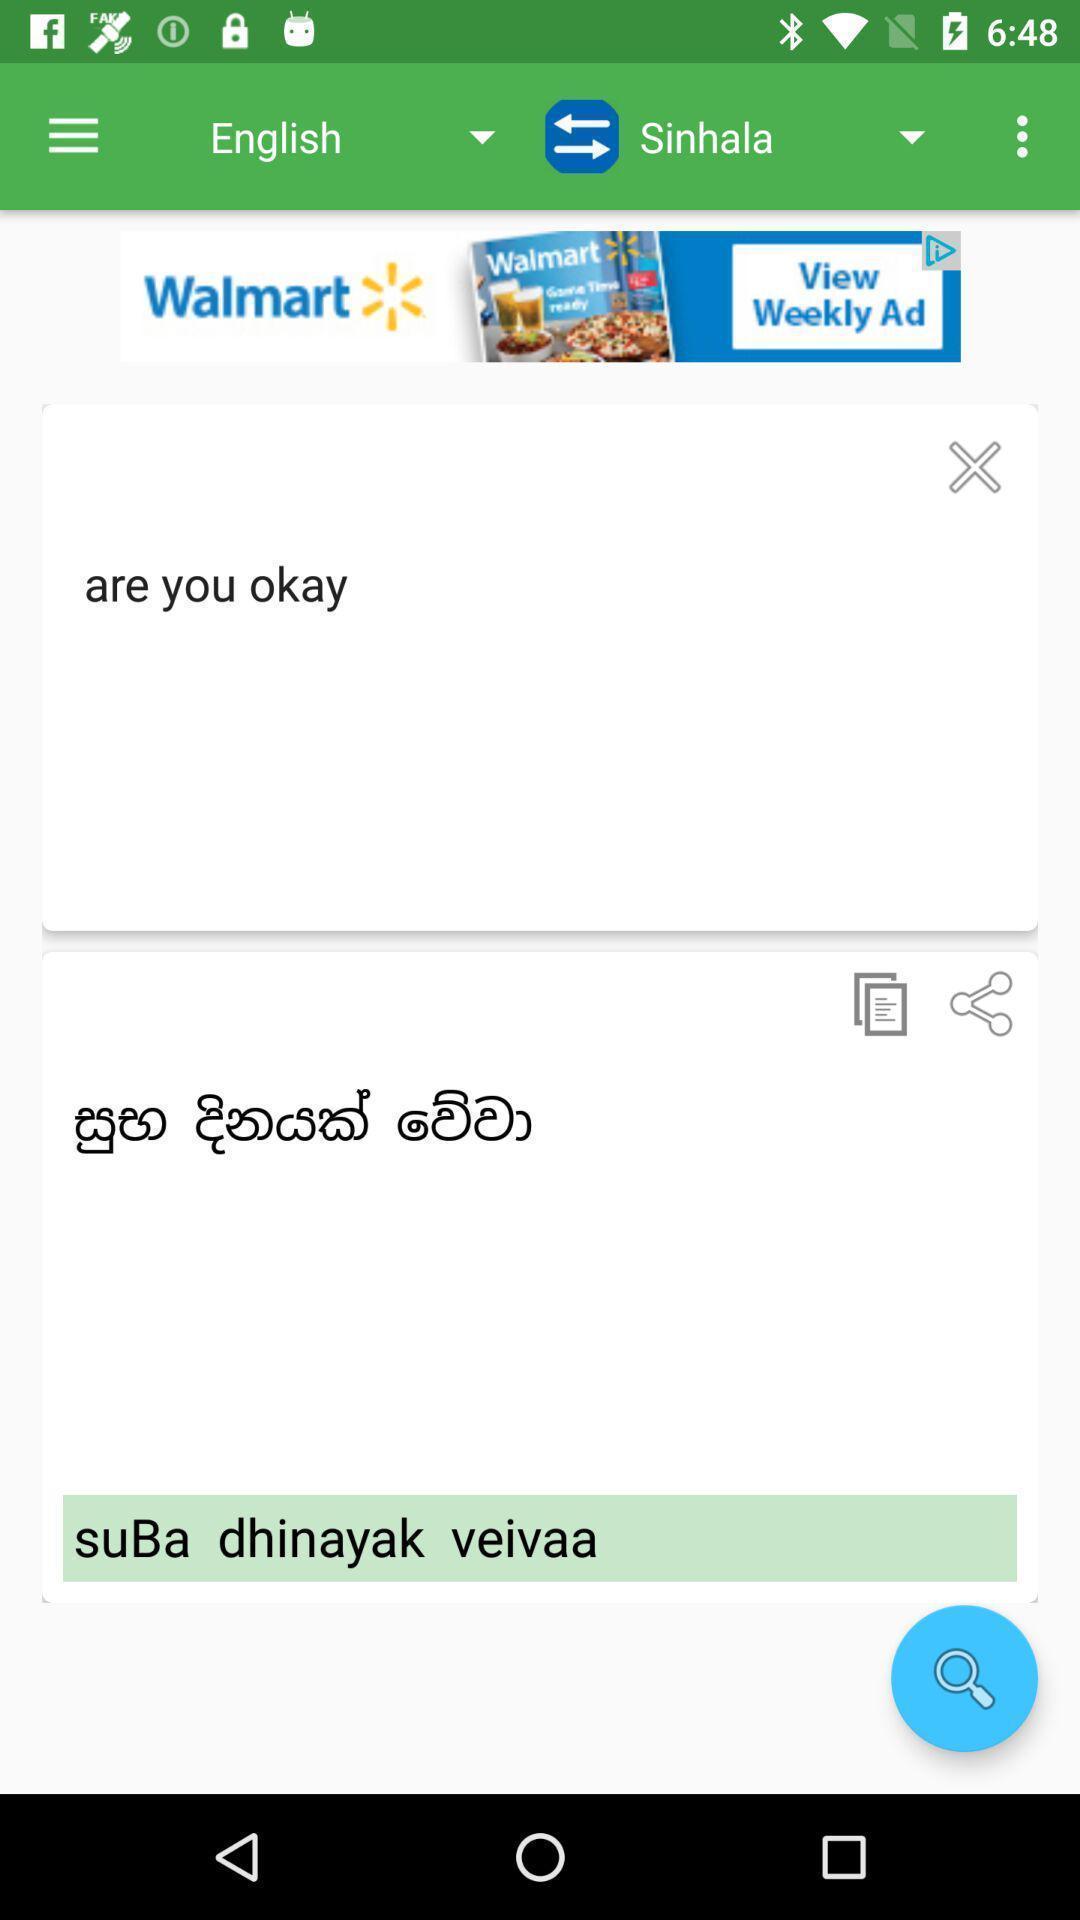Please provide a description for this image. Page displaying about translation application. 